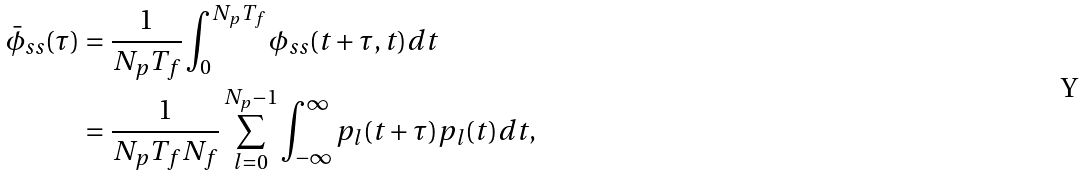Convert formula to latex. <formula><loc_0><loc_0><loc_500><loc_500>\bar { \phi } _ { s s } ( \tau ) & = \frac { 1 } { N _ { p } T _ { f } } \int _ { 0 } ^ { N _ { p } T _ { f } } \phi _ { s s } ( t + \tau , t ) d t \\ & = \frac { 1 } { N _ { p } T _ { f } N _ { f } } \sum _ { l = 0 } ^ { N _ { p } - 1 } \int _ { - \infty } ^ { \infty } p _ { l } ( t + \tau ) p _ { l } ( t ) d t ,</formula> 